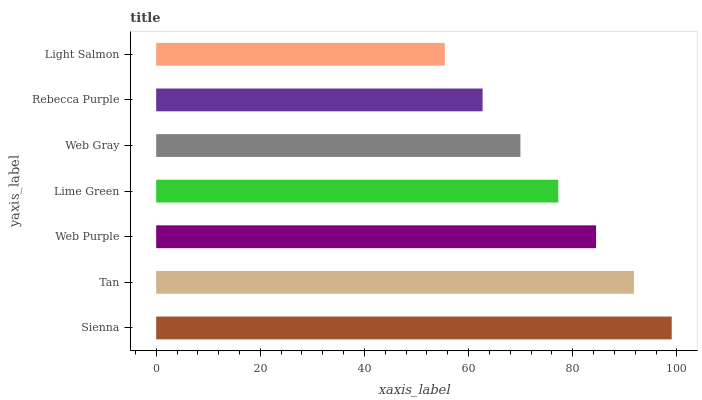Is Light Salmon the minimum?
Answer yes or no. Yes. Is Sienna the maximum?
Answer yes or no. Yes. Is Tan the minimum?
Answer yes or no. No. Is Tan the maximum?
Answer yes or no. No. Is Sienna greater than Tan?
Answer yes or no. Yes. Is Tan less than Sienna?
Answer yes or no. Yes. Is Tan greater than Sienna?
Answer yes or no. No. Is Sienna less than Tan?
Answer yes or no. No. Is Lime Green the high median?
Answer yes or no. Yes. Is Lime Green the low median?
Answer yes or no. Yes. Is Light Salmon the high median?
Answer yes or no. No. Is Rebecca Purple the low median?
Answer yes or no. No. 